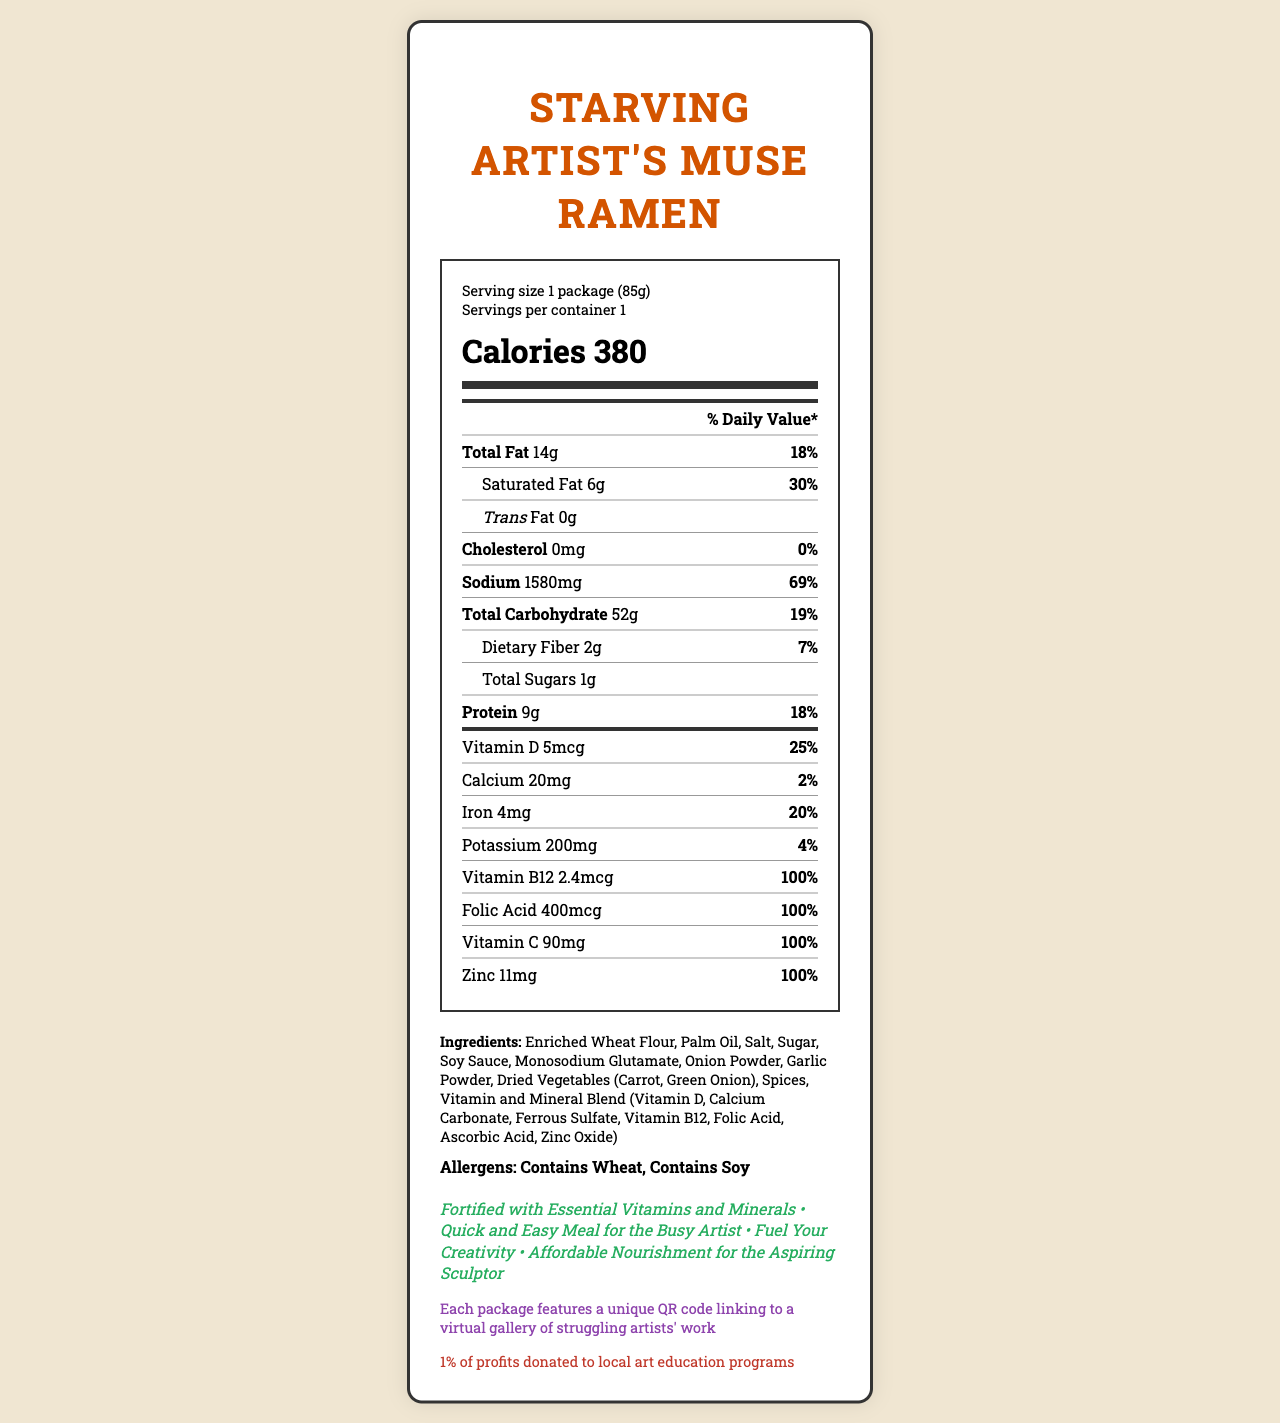what is the serving size? The serving size information is located at the top of the Nutrition Facts label under "Serving size".
Answer: 1 package (85g) how many calories are in one serving? The calories per serving are listed prominently in large font within the Nutrition Facts label.
Answer: 380 what is the total fat content and its daily value percentage? The Total Fat content and its Daily Value percentage are listed as "Total Fat 14g 18%" in the nutrient list.
Answer: 14g, 18% how much sodium does one serving contain? The sodium content for one serving is listed as "Sodium 1580mg" within the nutrient list.
Answer: 1580mg how many grams of protein are in each serving? The protein content per serving is listed as "Protein 9g" in the nutrient list.
Answer: 9g what allergens are included in the product? The allergens are listed near the bottom of the document under the "Allergens" section.
Answer: Contains Wheat, Contains Soy which vitamins and minerals cover 100% of the daily value? A. Vitamin D and Calcium B. Iron and Potassium C. Vitamin B12 and Zinc D. Vitamin C and Vitamin A Vitamin B12, Folic Acid, Vitamin C, and Zinc each cover 100% of the daily value according to the document.
Answer: C which of the following is a marketing claim made by this product? A. "Helps you lose weight" B. "Fortified with Essential Vitamins and Minerals" C. "Contains no preservatives" D. "Organic and GMO-free" One of the marketing claims in the document is "Fortified with Essential Vitamins and Minerals".
Answer: B does the product contain any cholesterol? The cholesterol content is listed as "0mg" with a 0% daily value in the nutrient list, indicating none is present.
Answer: No summarize the main idea of the document. The document offers a comprehensive overview of the nutritional content and marketing aspects of the instant ramen product, emphasizing its nutritional benefits and artistic support.
Answer: The document is the Nutrition Facts label for "Starving Artist's Muse Ramen". It provides detailed information about the serving size, calorie content, nutrient and vitamin levels, ingredients, allergens, and various marketing claims. The label highlights the inclusion of essential vitamins and minerals, geared towards providing nourishment for artists. The document also notes a charitable contribution to local art education programs and includes a QR code linking to a virtual gallery of artists' work. how much folic acid does one serving of ramen have? The folic acid amount is listed as "Folic Acid 400mcg" with a 100% daily value in the nutrient list.
Answer: 400mcg what percent of the daily value is the sodium content in one serving? The sodium content in one serving is listed as 1580mg with a daily value percentage of 69% in the nutrient list.
Answer: 69% how many grams of dietary fiber does each serving provide? The dietary fiber content per serving is listed as "Dietary Fiber 2g" in the nutrient list.
Answer: 2g how much Vitamin C does one serving contain? The Vitamin C content is listed as "Vitamin C 90mg" with a 100% daily value in the nutrient list.
Answer: 90mg how does the product support local art programs? The document states "1% of profits donated to local art education programs" near the bottom, indicating charitable contributions.
Answer: 1% of profits are donated to local art education programs are there any ingredients containing peanuts or dairy? The allergens are listed as "Contains Wheat, Contains Soy," and there is no mention of peanuts or dairy, so the answer based on the document is no. However, the exact ingredient list should be checked as this only confirms allergens mentioned.
Answer: Contains Wheat, Contains Soy 